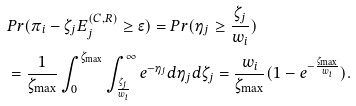<formula> <loc_0><loc_0><loc_500><loc_500>& P r ( \pi _ { i } - \zeta _ { j } E _ { j } ^ { ( C , R ) } \geq \epsilon ) = P r ( \eta _ { j } \geq \frac { \zeta _ { j } } { w _ { i } } ) \\ & = \frac { 1 } { \zeta _ { \max } } \int _ { 0 } ^ { \zeta _ { \max } } \int _ { \frac { \zeta _ { j } } { w _ { i } } } ^ { \infty } e ^ { - \eta _ { j } } d \eta _ { j } d \zeta _ { j } = \frac { w _ { i } } { \zeta _ { \max } } ( 1 - e ^ { - \frac { \zeta _ { \max } } { w _ { i } } } ) .</formula> 